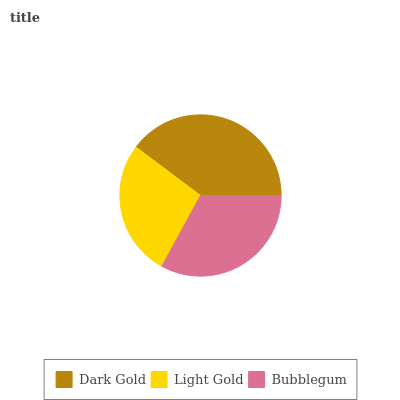Is Light Gold the minimum?
Answer yes or no. Yes. Is Dark Gold the maximum?
Answer yes or no. Yes. Is Bubblegum the minimum?
Answer yes or no. No. Is Bubblegum the maximum?
Answer yes or no. No. Is Bubblegum greater than Light Gold?
Answer yes or no. Yes. Is Light Gold less than Bubblegum?
Answer yes or no. Yes. Is Light Gold greater than Bubblegum?
Answer yes or no. No. Is Bubblegum less than Light Gold?
Answer yes or no. No. Is Bubblegum the high median?
Answer yes or no. Yes. Is Bubblegum the low median?
Answer yes or no. Yes. Is Light Gold the high median?
Answer yes or no. No. Is Dark Gold the low median?
Answer yes or no. No. 